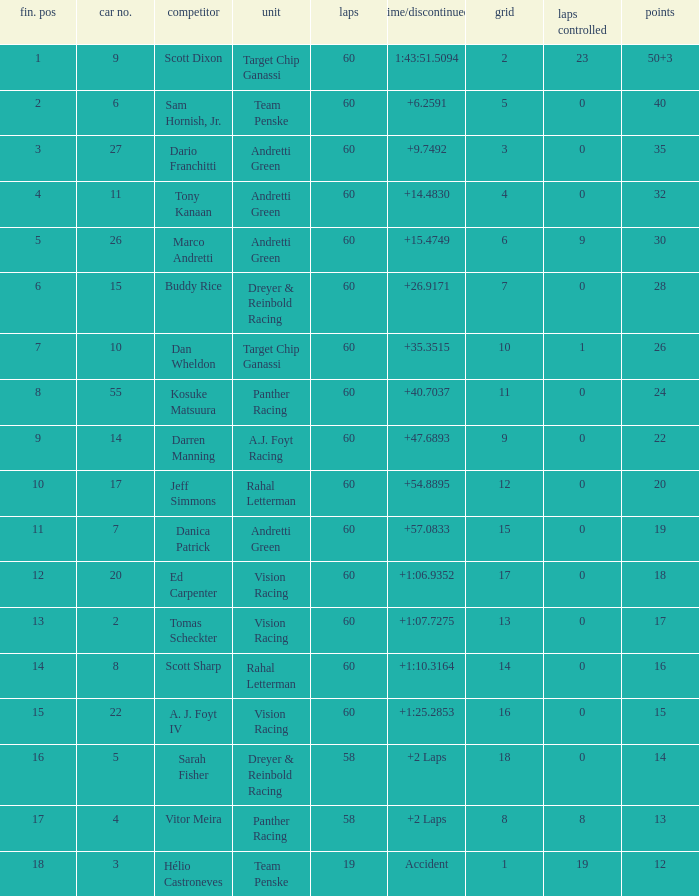Name the drive for points being 13 Vitor Meira. 